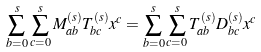<formula> <loc_0><loc_0><loc_500><loc_500>\sum _ { b = 0 } ^ { s } \sum _ { c = 0 } ^ { s } M ^ { ( s ) } _ { a b } T ^ { ( s ) } _ { b c } x ^ { c } = \sum _ { b = 0 } ^ { s } \sum _ { c = 0 } ^ { s } T ^ { ( s ) } _ { a b } D ^ { ( s ) } _ { b c } x ^ { c }</formula> 